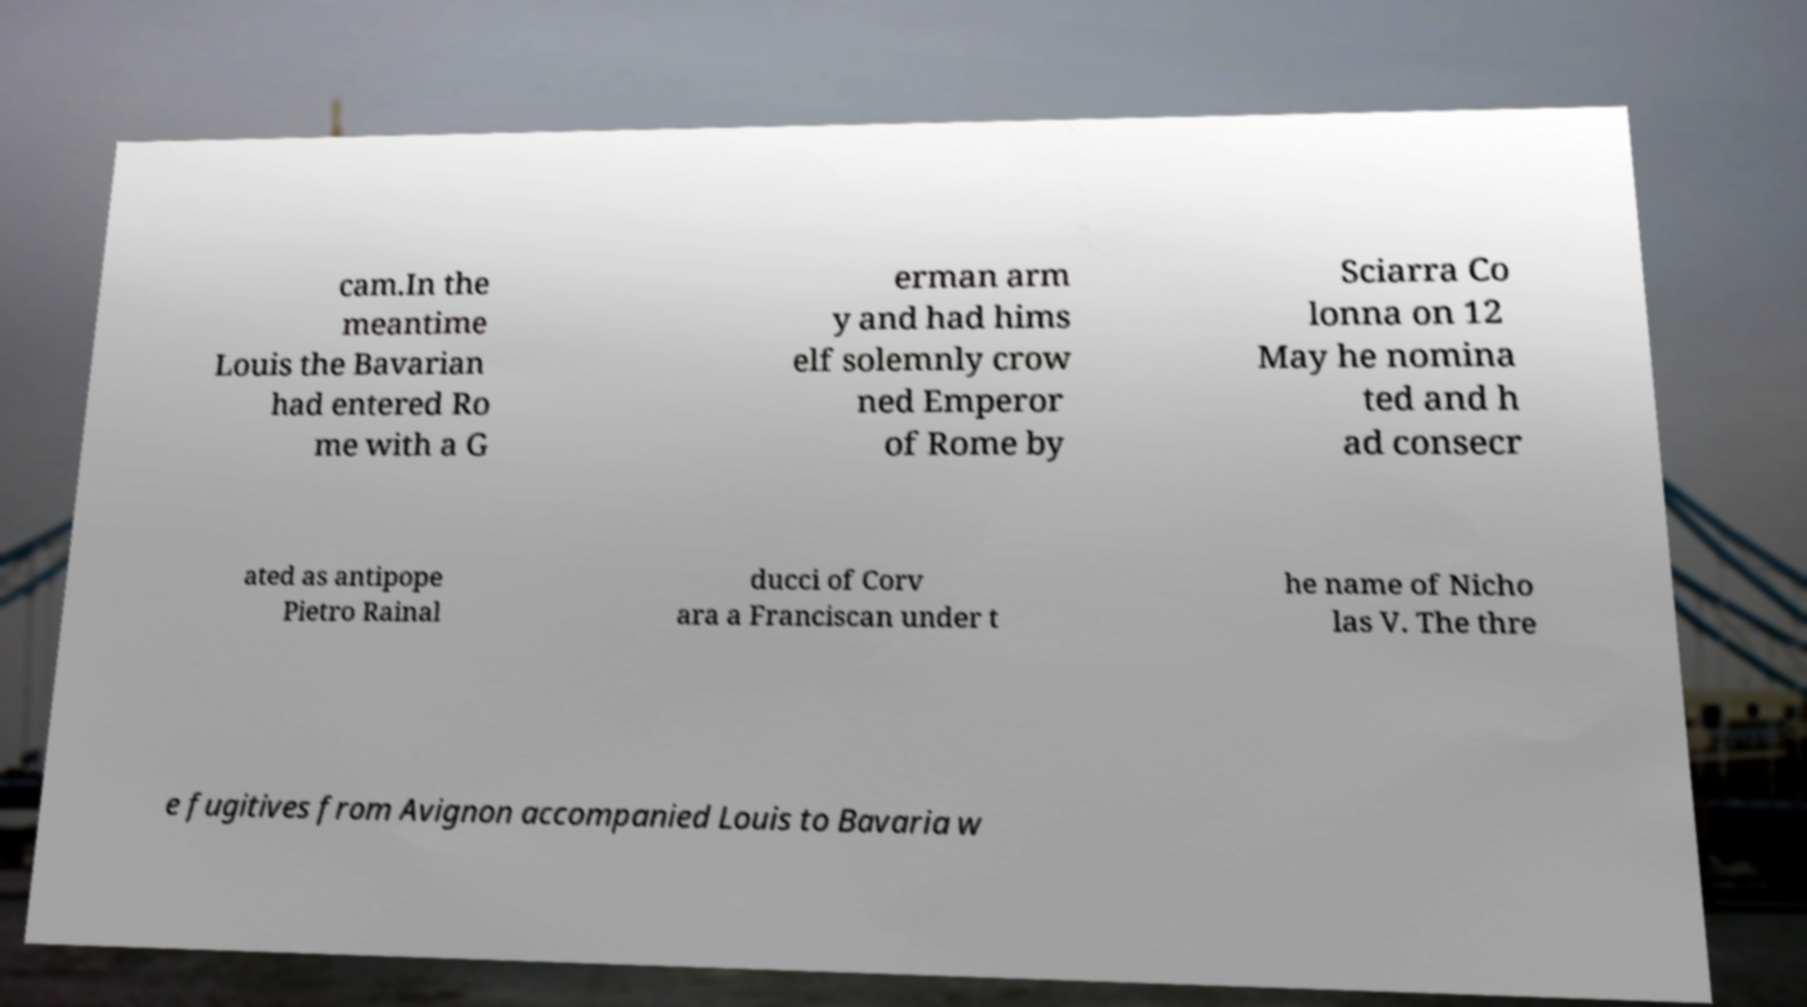Could you assist in decoding the text presented in this image and type it out clearly? cam.In the meantime Louis the Bavarian had entered Ro me with a G erman arm y and had hims elf solemnly crow ned Emperor of Rome by Sciarra Co lonna on 12 May he nomina ted and h ad consecr ated as antipope Pietro Rainal ducci of Corv ara a Franciscan under t he name of Nicho las V. The thre e fugitives from Avignon accompanied Louis to Bavaria w 